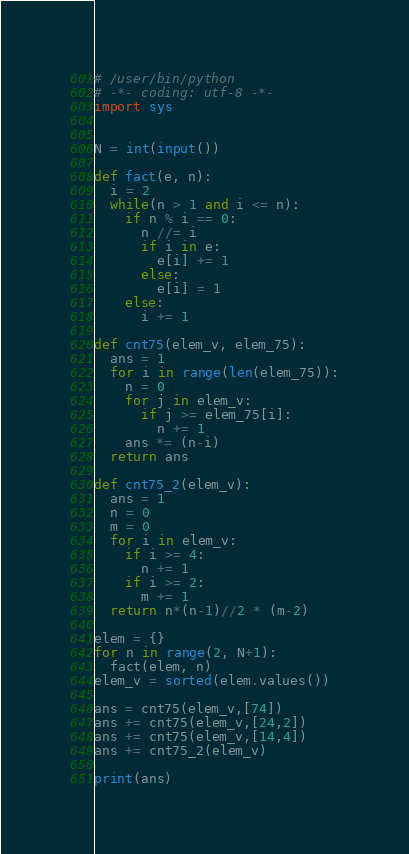Convert code to text. <code><loc_0><loc_0><loc_500><loc_500><_Python_># /user/bin/python
# -*- coding: utf-8 -*-
import sys 


N = int(input())

def fact(e, n):
  i = 2
  while(n > 1 and i <= n):
    if n % i == 0:
      n //= i
      if i in e:
        e[i] += 1
      else:
        e[i] = 1
    else:
      i += 1

def cnt75(elem_v, elem_75):
  ans = 1
  for i in range(len(elem_75)):
    n = 0
    for j in elem_v:
      if j >= elem_75[i]:
        n += 1
    ans *= (n-i)
  return ans    

def cnt75_2(elem_v):
  ans = 1
  n = 0
  m = 0
  for i in elem_v:
    if i >= 4:
      n += 1
    if i >= 2:
      m += 1
  return n*(n-1)//2 * (m-2)

elem = {}
for n in range(2, N+1):
  fact(elem, n)
elem_v = sorted(elem.values())

ans = cnt75(elem_v,[74])
ans += cnt75(elem_v,[24,2])
ans += cnt75(elem_v,[14,4])
ans += cnt75_2(elem_v)

print(ans)</code> 